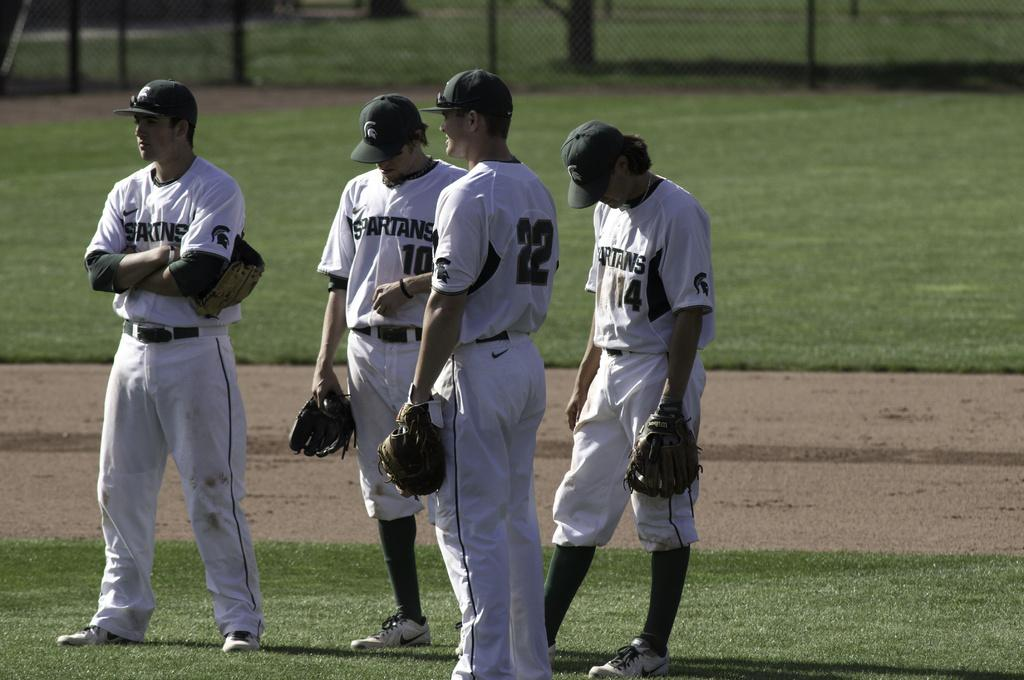<image>
Provide a brief description of the given image. a few players including one with the number 22 on 